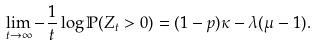Convert formula to latex. <formula><loc_0><loc_0><loc_500><loc_500>\lim _ { t \to \infty } - \frac { 1 } { t } \log \mathbb { P } ( Z _ { t } > 0 ) & = ( 1 - p ) \kappa - \lambda ( \mu - 1 ) .</formula> 